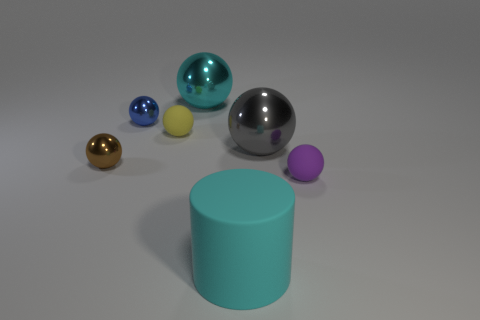How many big red things are there?
Make the answer very short. 0. Is there any other thing that is the same shape as the large rubber object?
Ensure brevity in your answer.  No. Is the material of the sphere that is to the right of the large gray metallic sphere the same as the big cyan thing in front of the yellow thing?
Keep it short and to the point. Yes. What is the material of the large gray object?
Give a very brief answer. Metal. What number of brown things are made of the same material as the large cyan ball?
Your answer should be very brief. 1. How many rubber objects are brown things or small things?
Give a very brief answer. 2. Do the small rubber object that is on the right side of the cyan metal sphere and the cyan object that is in front of the big gray object have the same shape?
Keep it short and to the point. No. What is the color of the large thing that is behind the brown thing and in front of the cyan metal thing?
Give a very brief answer. Gray. Do the thing that is in front of the tiny purple rubber object and the matte sphere that is behind the brown thing have the same size?
Your response must be concise. No. How many metal things have the same color as the large matte cylinder?
Make the answer very short. 1. 